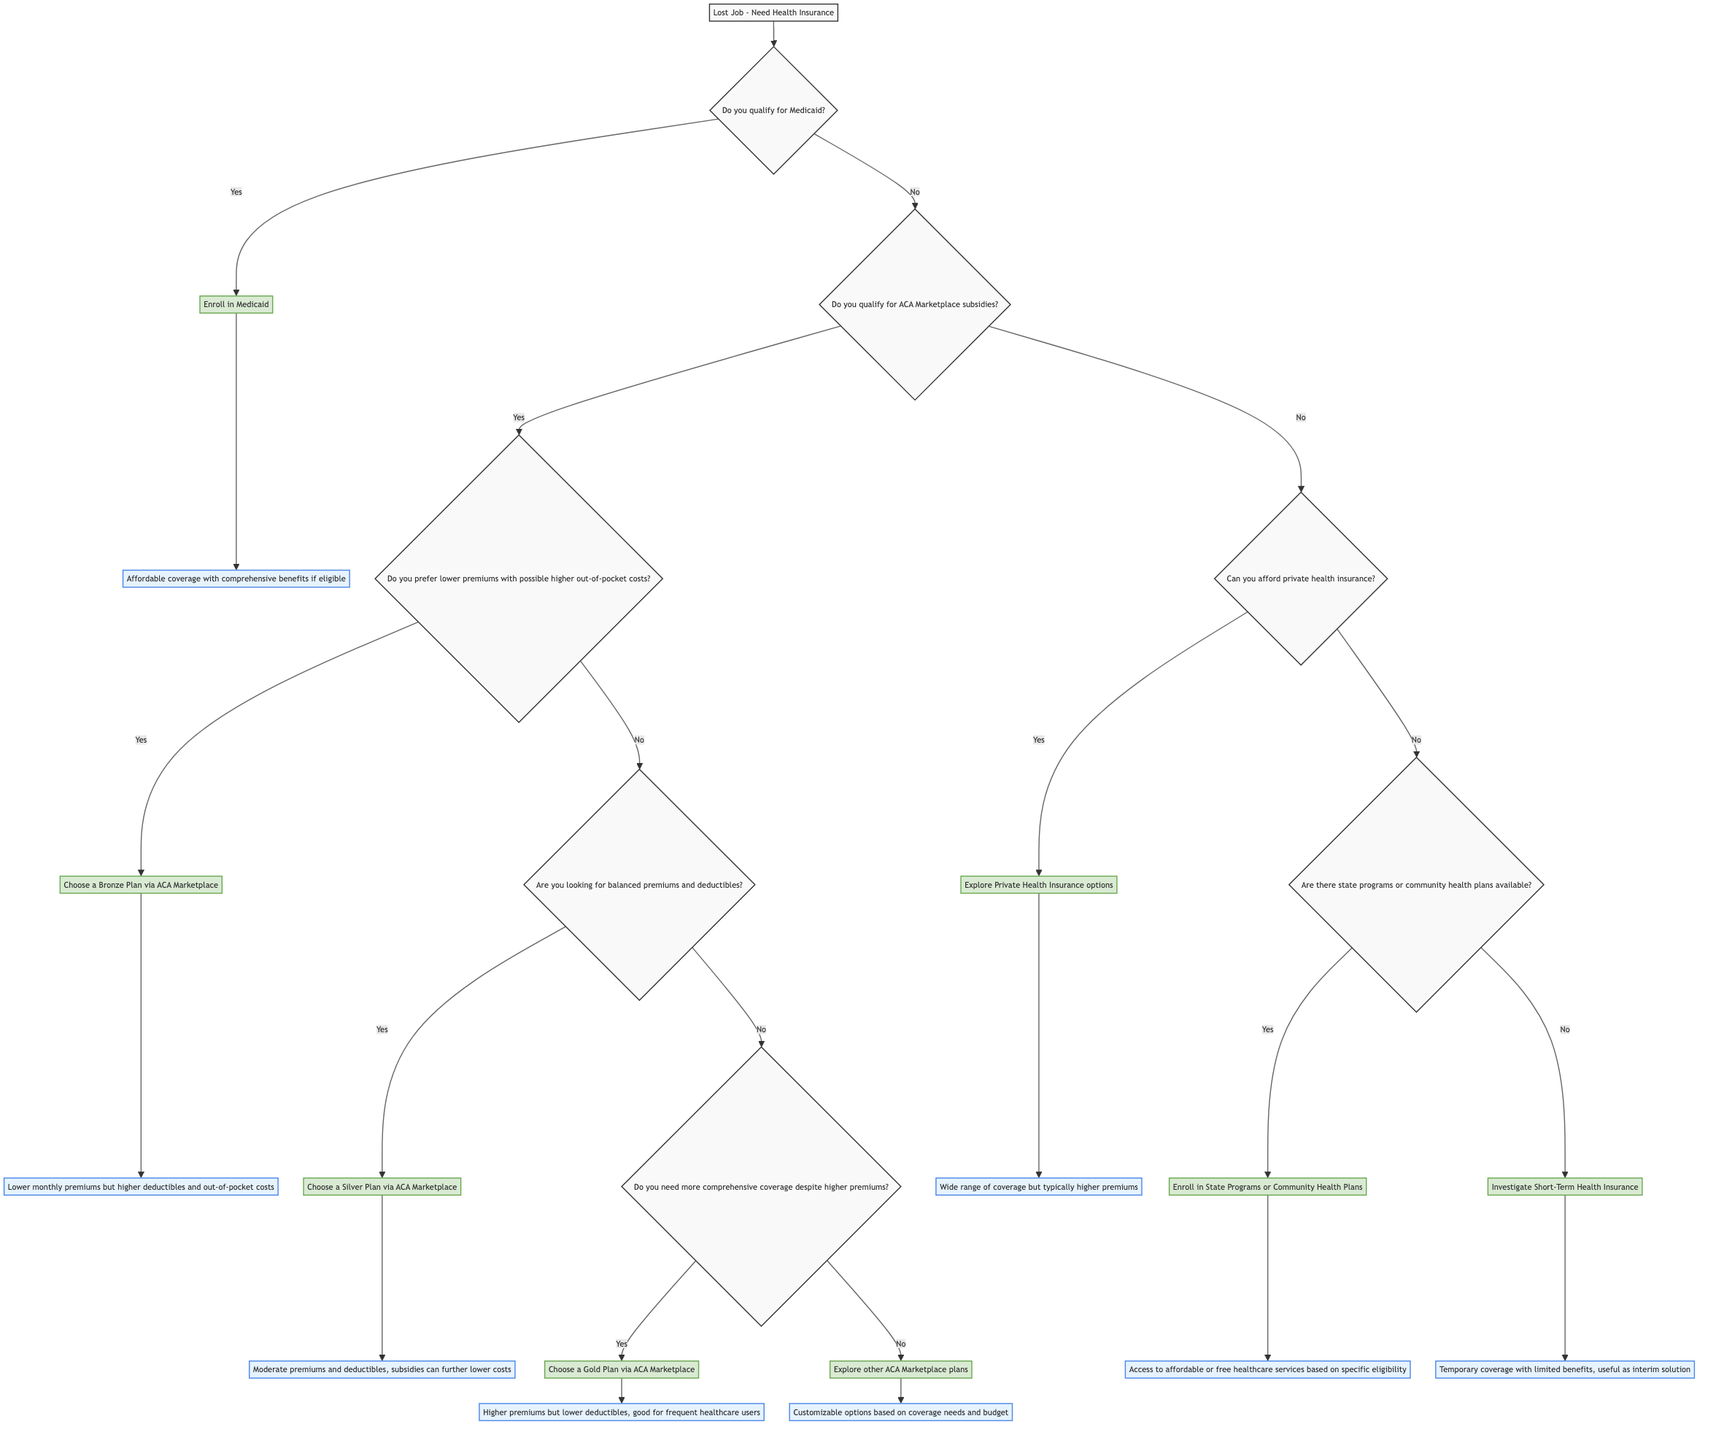What is the starting point of the decision tree? The starting point of the decision tree is labeled "Lost Job - Need Health Insurance." This means that the process begins here and is focused on finding health insurance after a job loss.
Answer: Lost Job - Need Health Insurance How many main criteria questions are in the diagram? There are two main criteria questions in the diagram: "Do you qualify for Medicaid?" and "Do you qualify for ACA Marketplace subsidies?" These questions guide the decision-making process regarding health insurance options.
Answer: 2 What action is taken if you qualify for Medicaid? If you qualify for Medicaid, the action taken is to "Enroll in Medicaid," which leads to affordable coverage with comprehensive benefits if eligible. This indicates that Medicaid is a viable option for those who qualify.
Answer: Enroll in Medicaid What do you choose if you prefer lower premiums with possible higher out-of-pocket costs? If you prefer lower premiums with possible higher out-of-pocket costs, you would choose a "Bronze Plan via ACA Marketplace." This plan offers lower monthly payments but comes with higher deductibles.
Answer: Choose a Bronze Plan via ACA Marketplace What is the outcome of choosing a Silver Plan via ACA Marketplace? Choosing a Silver Plan via ACA Marketplace results in "Moderate premiums and deductibles, subsidies can further lower costs." This indicates a balance between cost and coverage.
Answer: Moderate premiums and deductibles, subsidies can further lower costs What are the options if you cannot afford private health insurance? If you cannot afford private health insurance, the options are to check for state programs or community health plans or to investigate short-term health insurance. This decision reflects the need for affordable alternatives.
Answer: Check for state programs or community health plans or investigate short-term health insurance What happens if you choose to explore Private Health Insurance options? If you choose to explore Private Health Insurance options, the outcome is a "Wide range of coverage but typically higher premiums." This signifies that while there are various options, the cost may be a concern.
Answer: Wide range of coverage but typically higher premiums What leads to investigating Short-Term Health Insurance? Investigating Short-Term Health Insurance occurs if you cannot afford private health insurance and there are no state programs or community health plans available. This represents a temporary solution while seeking more permanent coverage.
Answer: Investigate Short-Term Health Insurance How does one access affordable healthcare if eligible for state programs? If eligible for state programs or community health plans, one can "Enroll in State Programs or Community Health Plans," which allows access to affordable or free healthcare services. This indicates that eligibility can significantly impact one's healthcare options.
Answer: Enroll in State Programs or Community Health Plans 